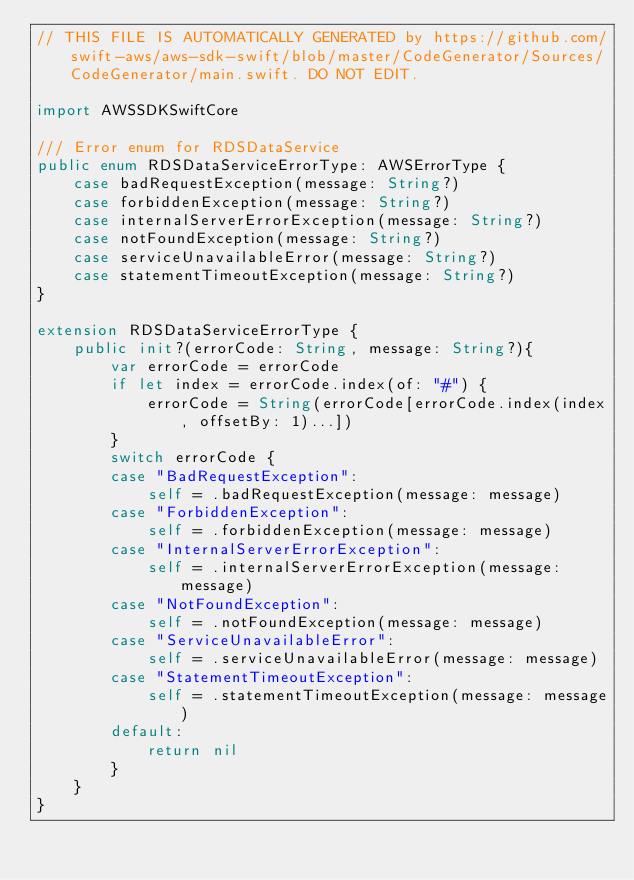Convert code to text. <code><loc_0><loc_0><loc_500><loc_500><_Swift_>// THIS FILE IS AUTOMATICALLY GENERATED by https://github.com/swift-aws/aws-sdk-swift/blob/master/CodeGenerator/Sources/CodeGenerator/main.swift. DO NOT EDIT.

import AWSSDKSwiftCore

/// Error enum for RDSDataService
public enum RDSDataServiceErrorType: AWSErrorType {
    case badRequestException(message: String?)
    case forbiddenException(message: String?)
    case internalServerErrorException(message: String?)
    case notFoundException(message: String?)
    case serviceUnavailableError(message: String?)
    case statementTimeoutException(message: String?)
}

extension RDSDataServiceErrorType {
    public init?(errorCode: String, message: String?){
        var errorCode = errorCode
        if let index = errorCode.index(of: "#") {
            errorCode = String(errorCode[errorCode.index(index, offsetBy: 1)...])
        }
        switch errorCode {
        case "BadRequestException":
            self = .badRequestException(message: message)
        case "ForbiddenException":
            self = .forbiddenException(message: message)
        case "InternalServerErrorException":
            self = .internalServerErrorException(message: message)
        case "NotFoundException":
            self = .notFoundException(message: message)
        case "ServiceUnavailableError":
            self = .serviceUnavailableError(message: message)
        case "StatementTimeoutException":
            self = .statementTimeoutException(message: message)
        default:
            return nil
        }
    }
}
</code> 